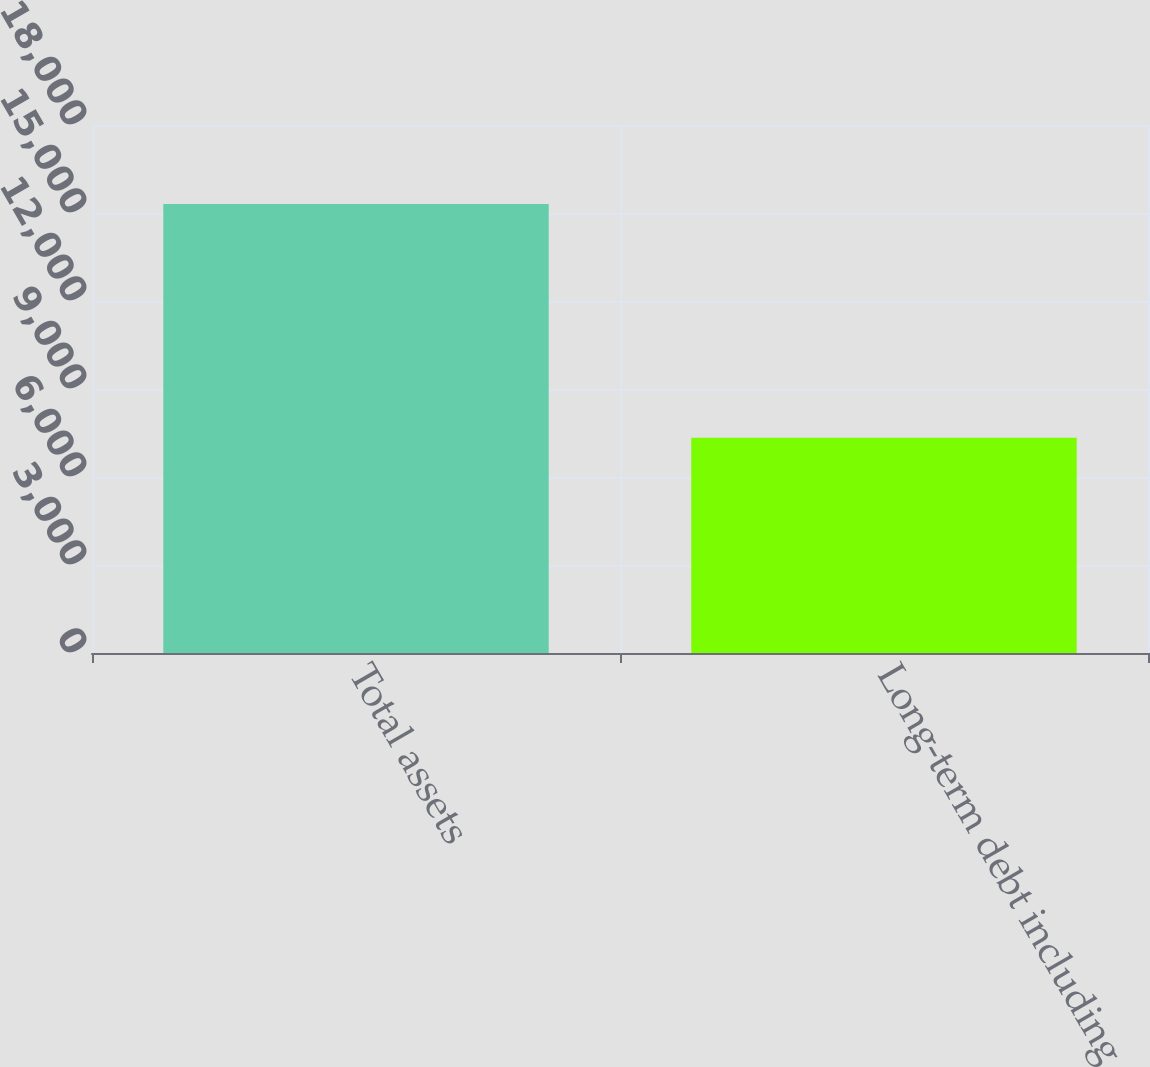<chart> <loc_0><loc_0><loc_500><loc_500><bar_chart><fcel>Total assets<fcel>Long-term debt including<nl><fcel>15303<fcel>7338<nl></chart> 